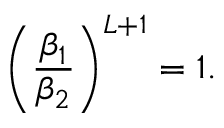Convert formula to latex. <formula><loc_0><loc_0><loc_500><loc_500>\left ( \frac { \beta _ { 1 } } { \beta _ { 2 } } \right ) ^ { L + 1 } = 1 .</formula> 